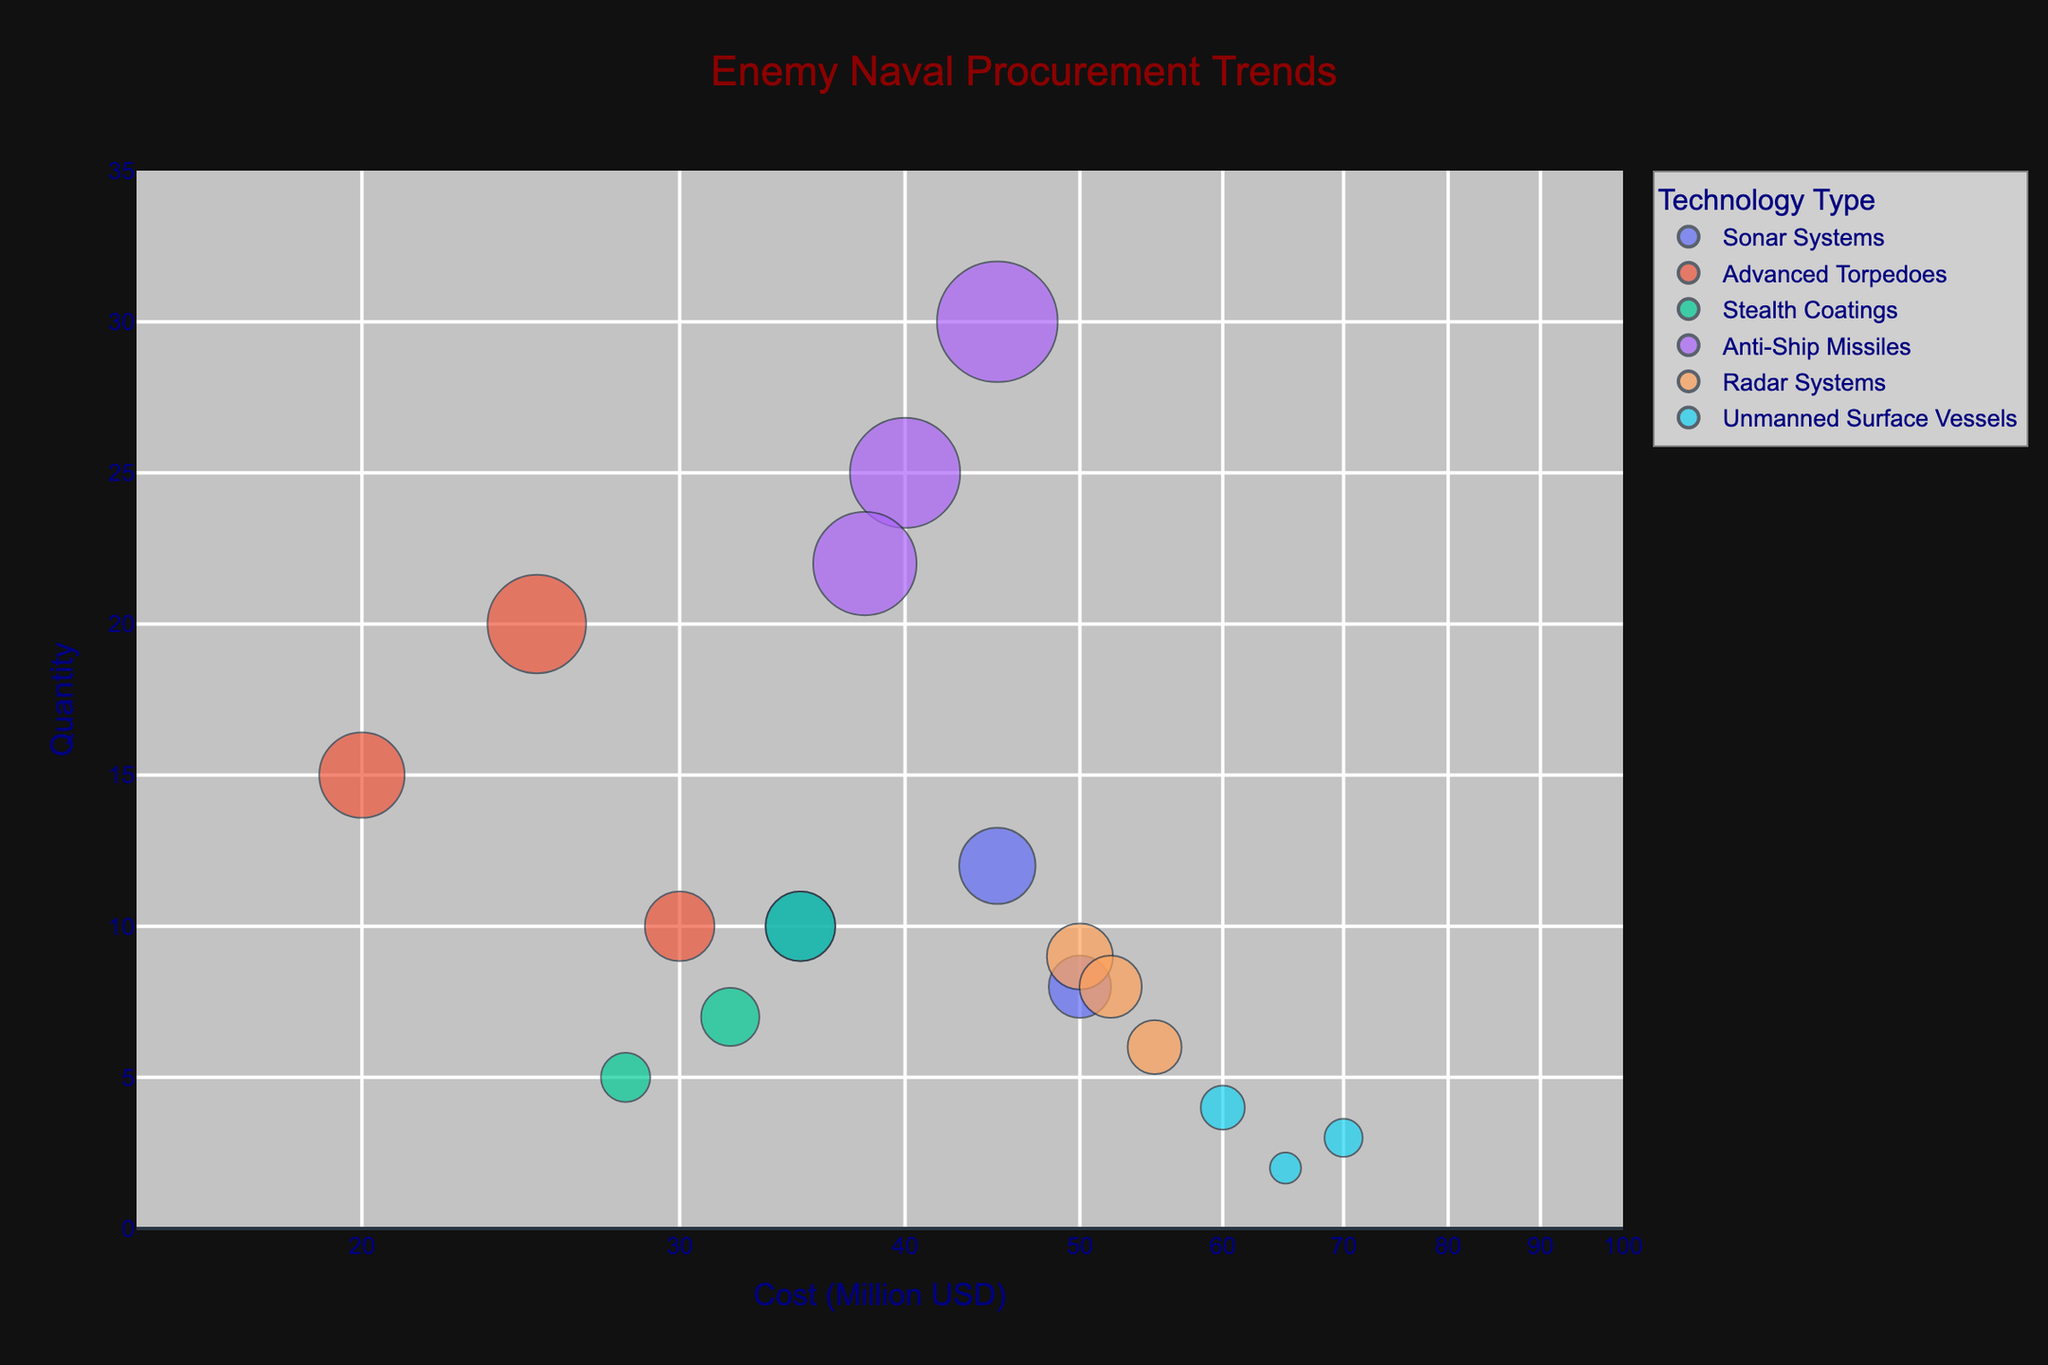What is the title of the chart? The title is written at the top of the chart.
Answer: Enemy Naval Procurement Trends How many unmanned surface vessels were procured from South Korea? Look for the bubble labeled 'South Korea' that falls under the 'Unmanned Surface Vessels' technology type and note the 'Number of Units'.
Answer: 2 Which vendor country has the highest cost for sonar systems? Check the 'Sonar Systems' bubbles and compare their 'Cost (in million USD)'. The highest value should be identified.
Answer: France What is the total number of advanced torpedoes units procured from all vendor countries? Sum up the 'Number of Units' for all 'Advanced Torpedoes' data points.
Answer: 45 Which technology type has the fewest total units procured? Sum up the 'Number of Units' for each 'Technology Type' and compare.
Answer: Stealth Coatings How does the cost of radar systems from Israel compare to those from the UK? Compare the 'Cost (in million USD)' of 'Radar Systems' labeled 'Israel' and 'UK'.
Answer: Israel is more expensive Which technology type has the widest range in cost? For each technology type, calculate the range (difference between the highest and lowest cost).
Answer: Unmanned Surface Vessels What is the average cost of anti-ship missiles? Add the 'Cost (in million USD)' values for all 'Anti-Ship Missiles' and divide by the number of data points (3). (40 + 45 + 38) / 3 = 41
Answer: 41 million USD Between sonar systems and stealth coatings, which has the higher total cost? Sum the 'Cost (in million USD)' for each of the two technology types and compare.
Answer: Sonar Systems Which vendor country supplies the cheapest unmanned surface vessels? Look at the 'Cost (in million USD)' for all 'Unmanned Surface Vessels' and identify the smallest value and its corresponding vendor country.
Answer: China 